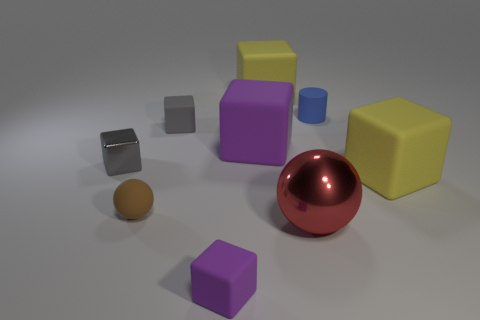What is the big red ball made of?
Ensure brevity in your answer.  Metal. There is a big block right of the rubber cylinder; what is its material?
Provide a succinct answer. Rubber. Is there any other thing that is the same color as the tiny metallic block?
Make the answer very short. Yes. There is a block that is made of the same material as the red thing; what size is it?
Your answer should be compact. Small. How many tiny objects are either brown rubber balls or cyan metal cylinders?
Your response must be concise. 1. How big is the purple rubber cube that is in front of the yellow rubber object in front of the gray object on the left side of the tiny brown rubber ball?
Give a very brief answer. Small. How many brown spheres have the same size as the red shiny thing?
Your answer should be very brief. 0. How many things are either large purple cylinders or yellow things that are behind the small gray metal thing?
Provide a succinct answer. 1. What shape is the brown thing?
Your response must be concise. Sphere. Does the tiny cylinder have the same color as the tiny rubber ball?
Offer a terse response. No. 